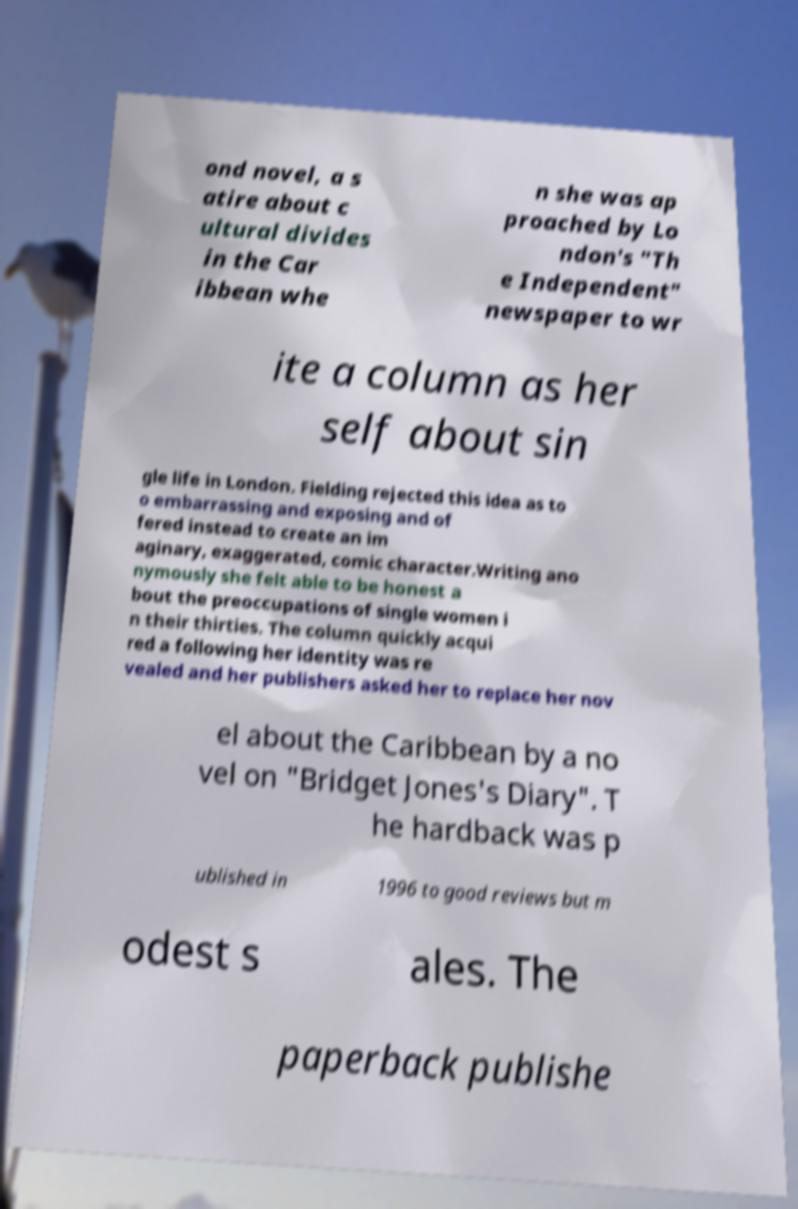Please read and relay the text visible in this image. What does it say? ond novel, a s atire about c ultural divides in the Car ibbean whe n she was ap proached by Lo ndon's "Th e Independent" newspaper to wr ite a column as her self about sin gle life in London. Fielding rejected this idea as to o embarrassing and exposing and of fered instead to create an im aginary, exaggerated, comic character.Writing ano nymously she felt able to be honest a bout the preoccupations of single women i n their thirties. The column quickly acqui red a following her identity was re vealed and her publishers asked her to replace her nov el about the Caribbean by a no vel on "Bridget Jones's Diary". T he hardback was p ublished in 1996 to good reviews but m odest s ales. The paperback publishe 